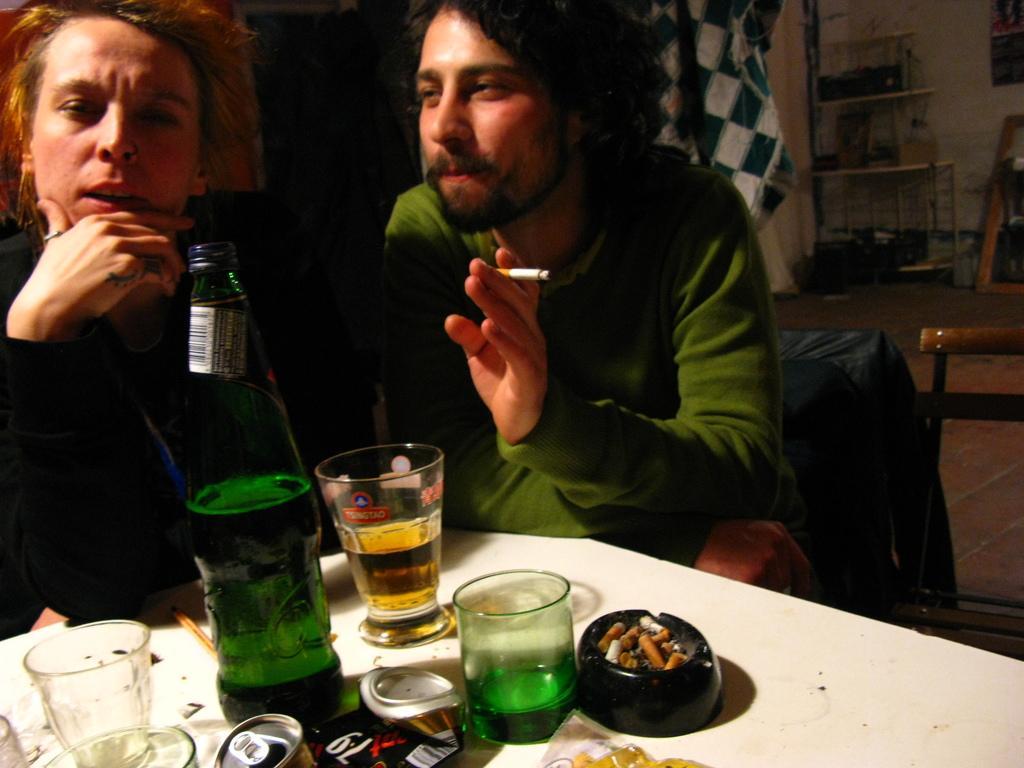Can you describe this image briefly? In this image I can see a man and a woman. I can see he is holding a cigarette in his fingers. Here on this table I can see a bottle and few glasses. 